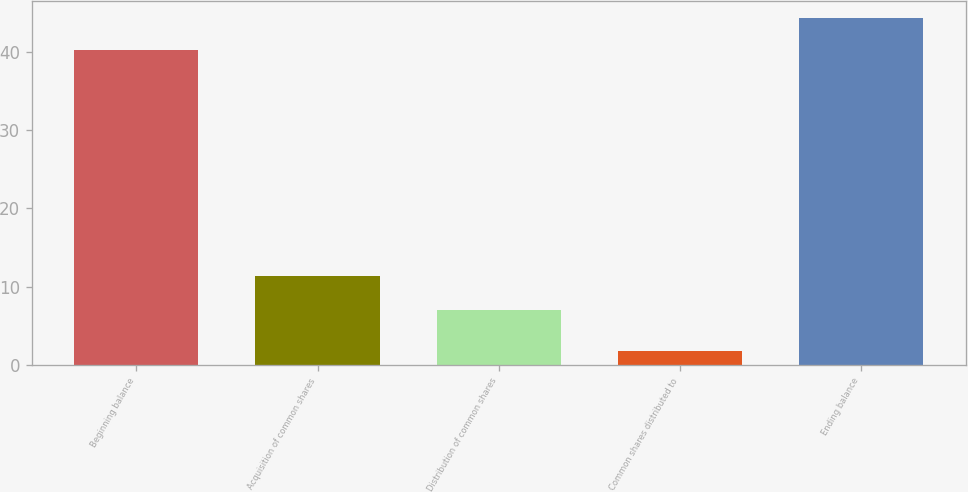Convert chart to OTSL. <chart><loc_0><loc_0><loc_500><loc_500><bar_chart><fcel>Beginning balance<fcel>Acquisition of common shares<fcel>Distribution of common shares<fcel>Common shares distributed to<fcel>Ending balance<nl><fcel>40.2<fcel>11.3<fcel>7<fcel>1.8<fcel>44.29<nl></chart> 